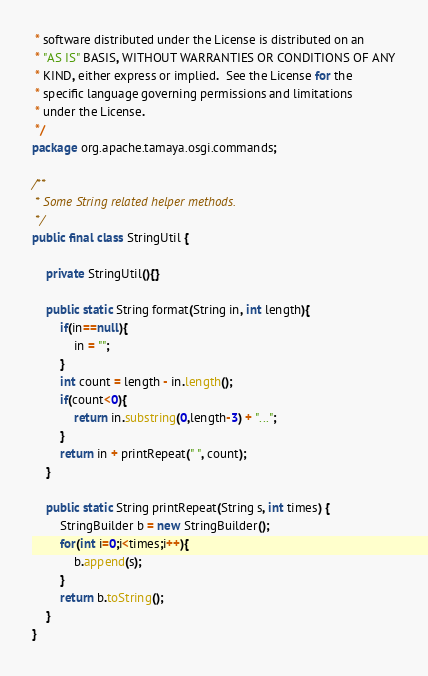Convert code to text. <code><loc_0><loc_0><loc_500><loc_500><_Java_> * software distributed under the License is distributed on an
 * "AS IS" BASIS, WITHOUT WARRANTIES OR CONDITIONS OF ANY
 * KIND, either express or implied.  See the License for the
 * specific language governing permissions and limitations
 * under the License.
 */
package org.apache.tamaya.osgi.commands;

/**
 * Some String related helper methods.
 */
public final class StringUtil {

    private StringUtil(){}

    public static String format(String in, int length){
        if(in==null){
            in = "";
        }
        int count = length - in.length();
        if(count<0){
            return in.substring(0,length-3) + "...";
        }
        return in + printRepeat(" ", count);
    }

    public static String printRepeat(String s, int times) {
        StringBuilder b = new StringBuilder();
        for(int i=0;i<times;i++){
            b.append(s);
        }
        return b.toString();
    }
}
</code> 